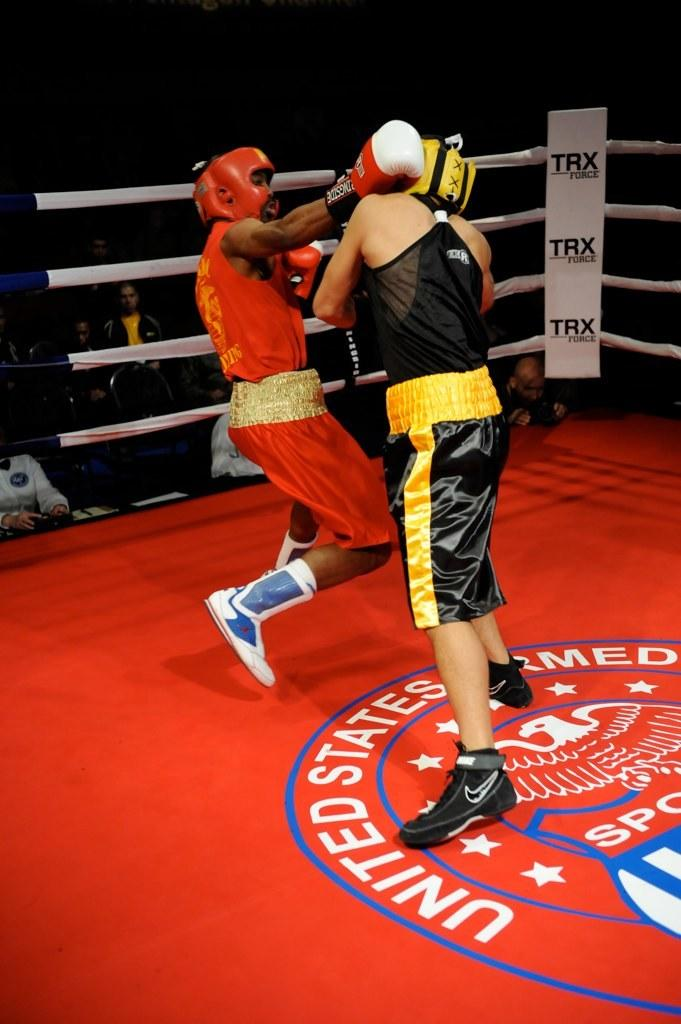<image>
Provide a brief description of the given image. Tow men box on a mat that has a United States military seal on it. 